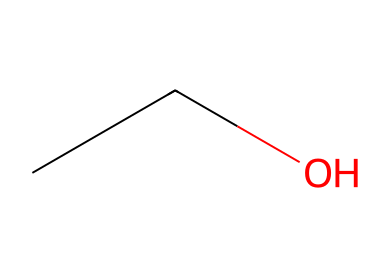How many carbon atoms are in ethanol? The SMILES representation "CCO" indicates that there are two carbon atoms (C) present in the structure based on the two "C" symbols before the "O".
Answer: 2 What is the chemical name of this compound? The SMILES representation "CCO" corresponds to ethanol, which is commonly known as alcohol.
Answer: ethanol How many hydrogen atoms are present in ethanol? In the SMILES notation "CCO", each carbon atom typically bonds with enough hydrogen atoms to satisfy four bonds. Therefore, for C2, there are 6 hydrogen atoms (H) in total, considering the -OH group.
Answer: 6 Is ethanol polar or non-polar? The presence of the -OH (hydroxyl) group in the structure indicates that ethanol can form hydrogen bonds, making it a polar solvent. Thus, it exhibits both polar and non-polar characteristics due to its hydrocarbon part and functional group.
Answer: polar What functional group is present in ethanol? In the SMILES structure "CCO", the -OH (hydroxyl) group denotes the presence of an alcohol functional group, which is characteristic of ethanol.
Answer: alcohol Does this compound have a high or low volatility? Ethanol is characterized as having relatively high volatility due to its low molecular weight and weaker intermolecular forces compared to larger molecules, allowing it to evaporate quickly.
Answer: high What type of solvent is ethanol classified as? Ethanol acts as a polar protic solvent, which means it can dissolve both ionic and polar substances due to its ability to donate hydrogen bonds.
Answer: polar protic solvent 